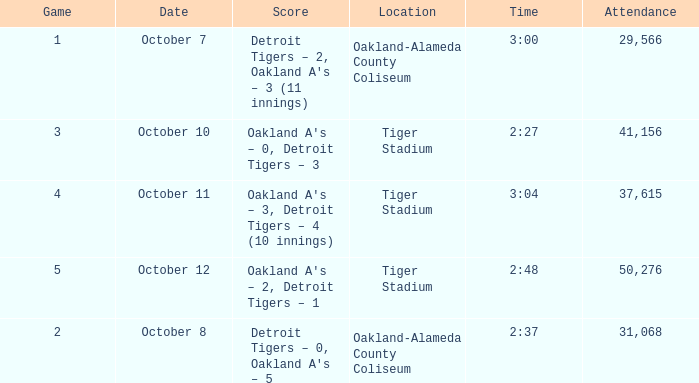What is the number of people in attendance at Oakland-Alameda County Coliseum, and game is 2? 31068.0. 